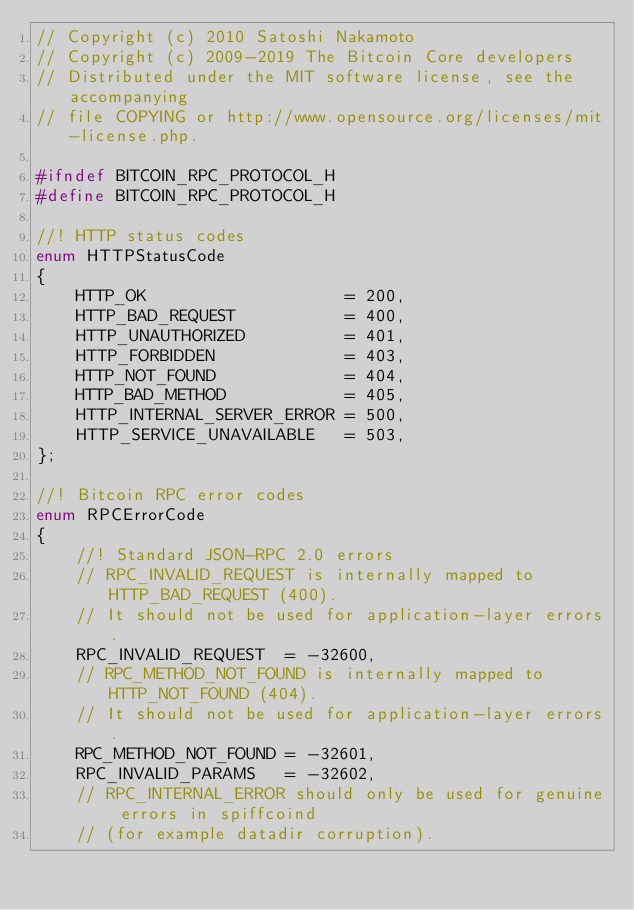<code> <loc_0><loc_0><loc_500><loc_500><_C_>// Copyright (c) 2010 Satoshi Nakamoto
// Copyright (c) 2009-2019 The Bitcoin Core developers
// Distributed under the MIT software license, see the accompanying
// file COPYING or http://www.opensource.org/licenses/mit-license.php.

#ifndef BITCOIN_RPC_PROTOCOL_H
#define BITCOIN_RPC_PROTOCOL_H

//! HTTP status codes
enum HTTPStatusCode
{
    HTTP_OK                    = 200,
    HTTP_BAD_REQUEST           = 400,
    HTTP_UNAUTHORIZED          = 401,
    HTTP_FORBIDDEN             = 403,
    HTTP_NOT_FOUND             = 404,
    HTTP_BAD_METHOD            = 405,
    HTTP_INTERNAL_SERVER_ERROR = 500,
    HTTP_SERVICE_UNAVAILABLE   = 503,
};

//! Bitcoin RPC error codes
enum RPCErrorCode
{
    //! Standard JSON-RPC 2.0 errors
    // RPC_INVALID_REQUEST is internally mapped to HTTP_BAD_REQUEST (400).
    // It should not be used for application-layer errors.
    RPC_INVALID_REQUEST  = -32600,
    // RPC_METHOD_NOT_FOUND is internally mapped to HTTP_NOT_FOUND (404).
    // It should not be used for application-layer errors.
    RPC_METHOD_NOT_FOUND = -32601,
    RPC_INVALID_PARAMS   = -32602,
    // RPC_INTERNAL_ERROR should only be used for genuine errors in spiffcoind
    // (for example datadir corruption).</code> 